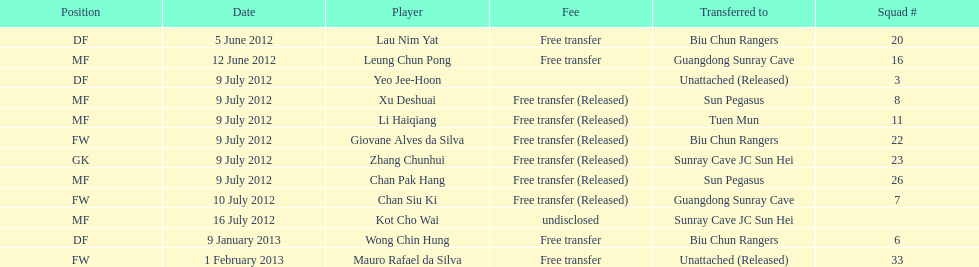Li haiqiang and xu deshuai both occupied which role? MF. 